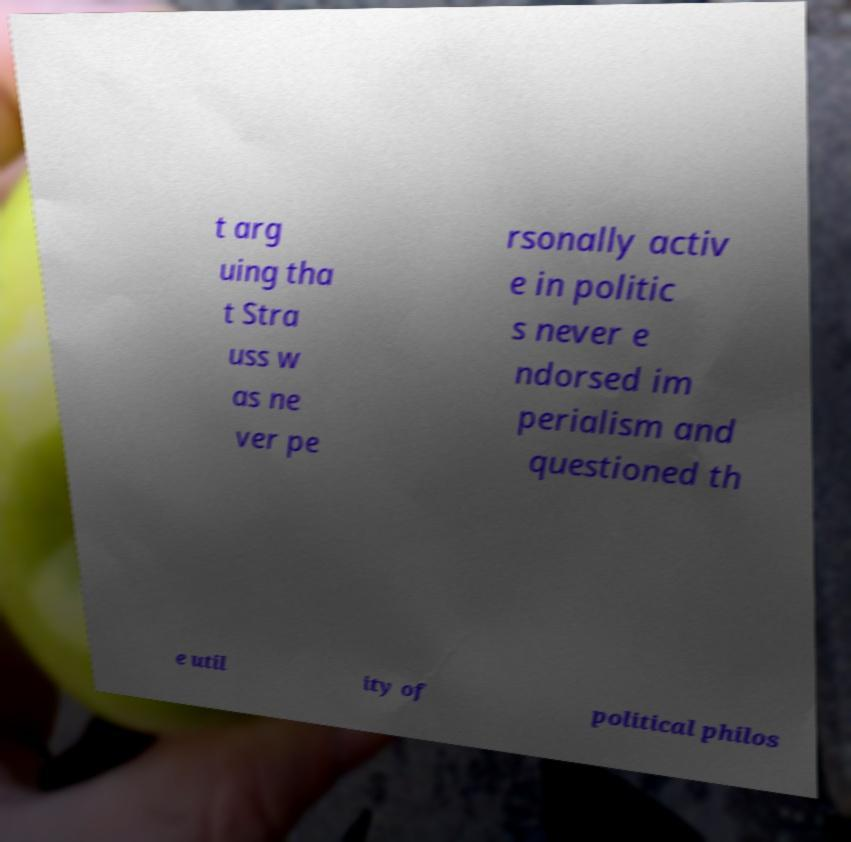What messages or text are displayed in this image? I need them in a readable, typed format. t arg uing tha t Stra uss w as ne ver pe rsonally activ e in politic s never e ndorsed im perialism and questioned th e util ity of political philos 